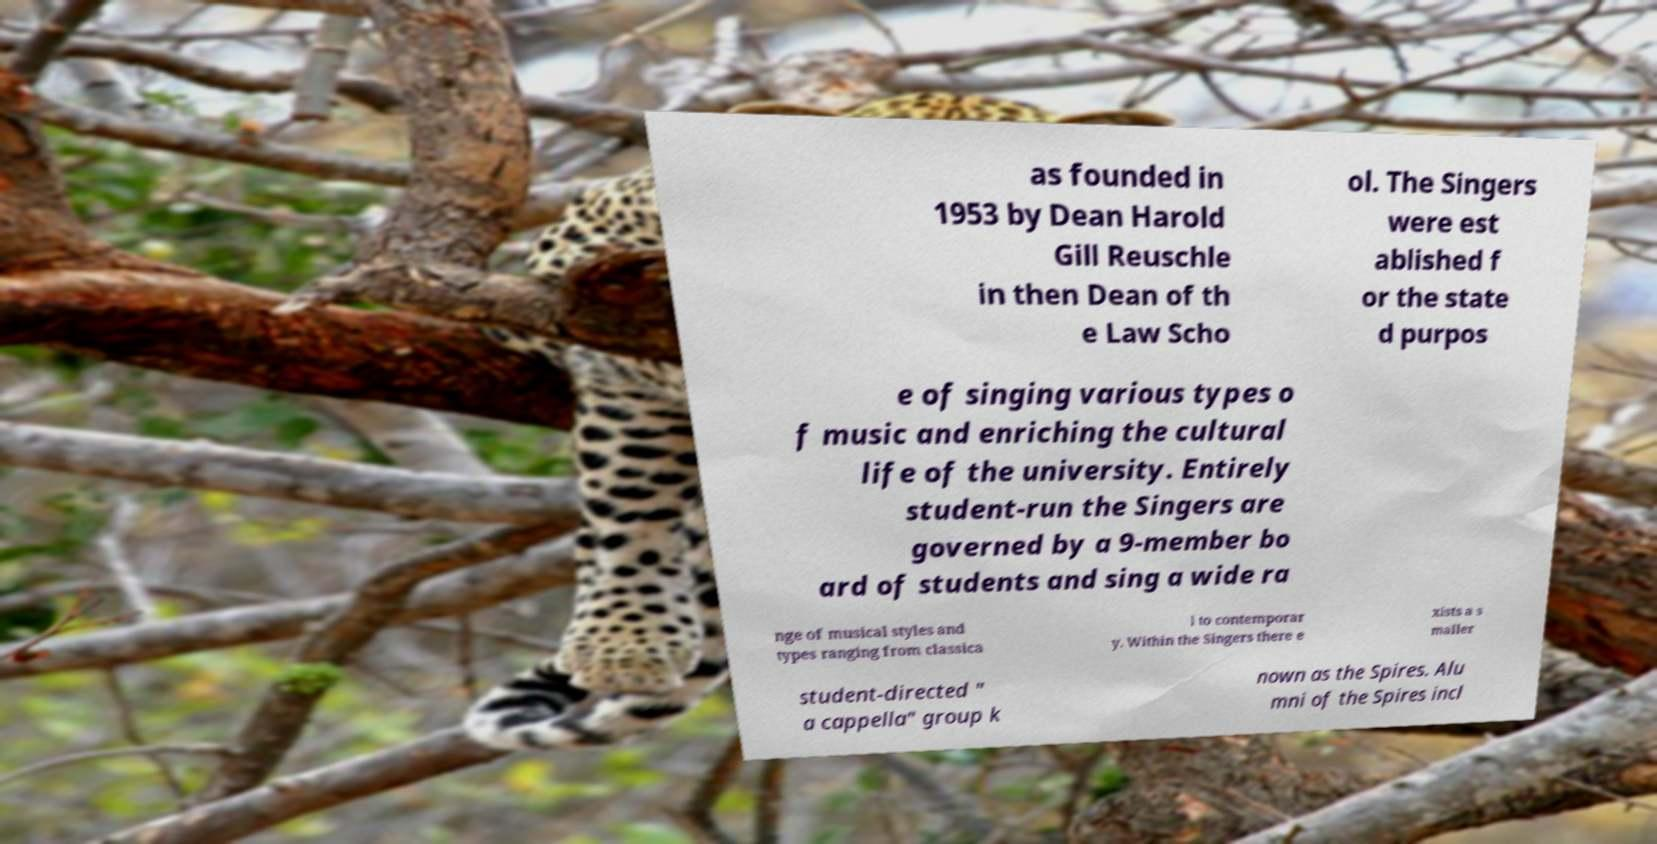Can you read and provide the text displayed in the image?This photo seems to have some interesting text. Can you extract and type it out for me? as founded in 1953 by Dean Harold Gill Reuschle in then Dean of th e Law Scho ol. The Singers were est ablished f or the state d purpos e of singing various types o f music and enriching the cultural life of the university. Entirely student-run the Singers are governed by a 9-member bo ard of students and sing a wide ra nge of musical styles and types ranging from classica l to contemporar y. Within the Singers there e xists a s maller student-directed " a cappella" group k nown as the Spires. Alu mni of the Spires incl 